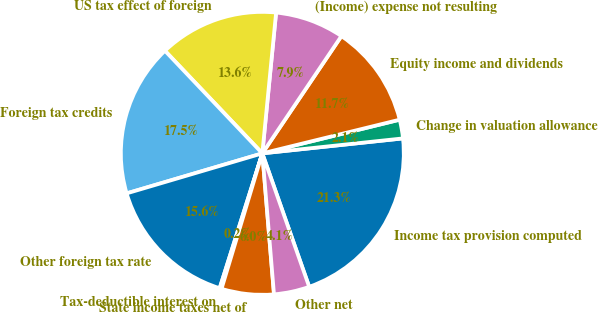Convert chart. <chart><loc_0><loc_0><loc_500><loc_500><pie_chart><fcel>Income tax provision computed<fcel>Change in valuation allowance<fcel>Equity income and dividends<fcel>(Income) expense not resulting<fcel>US tax effect of foreign<fcel>Foreign tax credits<fcel>Other foreign tax rate<fcel>Tax-deductible interest on<fcel>State income taxes net of<fcel>Other net<nl><fcel>21.31%<fcel>2.14%<fcel>11.73%<fcel>7.89%<fcel>13.64%<fcel>17.48%<fcel>15.56%<fcel>0.22%<fcel>5.97%<fcel>4.06%<nl></chart> 